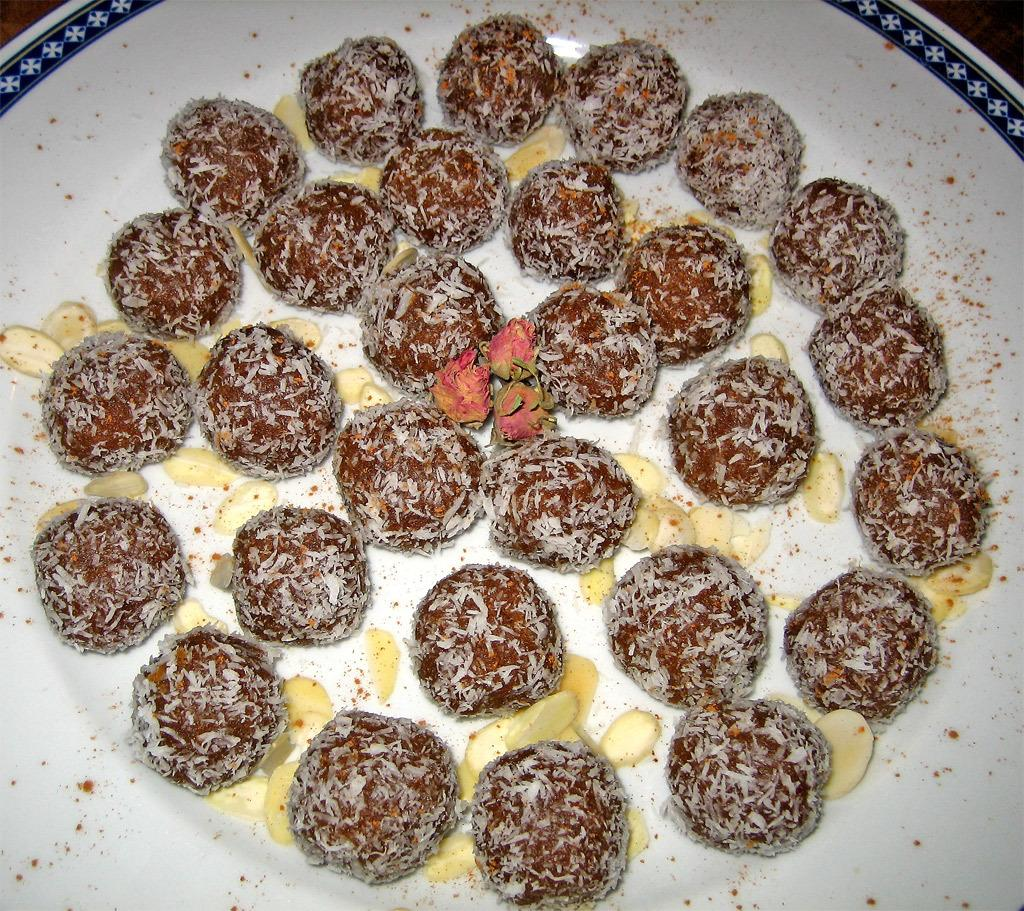What is present on the plate in the image? There are food items on a plate in the image. Is there smoke coming from the food items on the plate in the image? No, there is no smoke present in the image. What type of appliance is used to prepare the food items on the plate in the image? The provided facts do not mention any appliances used to prepare the food items, so it cannot be determined from the image. 